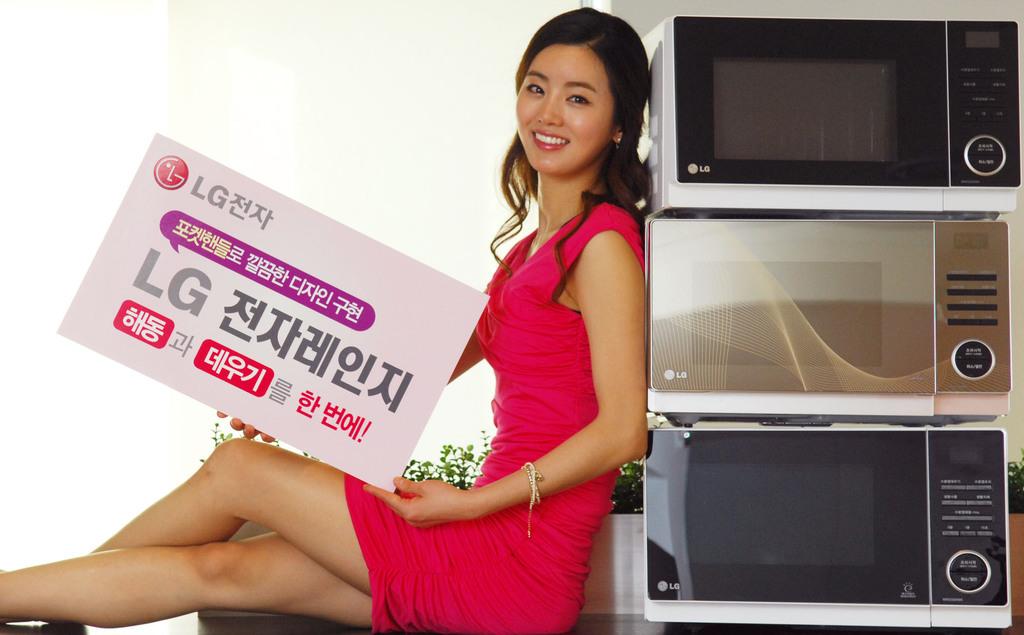What brand is depicted?
Provide a succinct answer. Lg. What items are featured in this ad?
Offer a very short reply. Lg. 